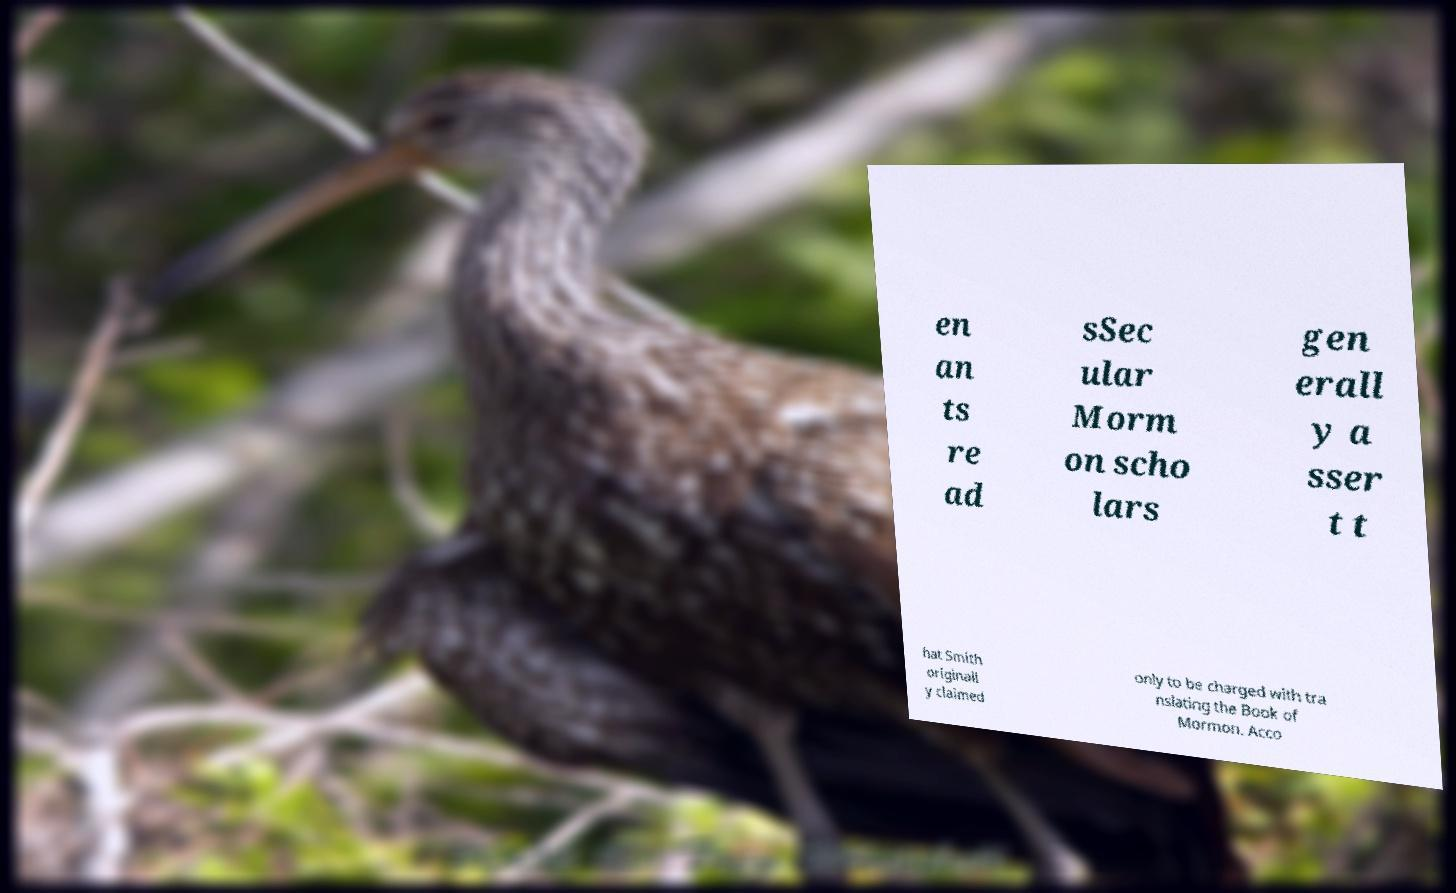Can you read and provide the text displayed in the image?This photo seems to have some interesting text. Can you extract and type it out for me? en an ts re ad sSec ular Morm on scho lars gen erall y a sser t t hat Smith originall y claimed only to be charged with tra nslating the Book of Mormon. Acco 